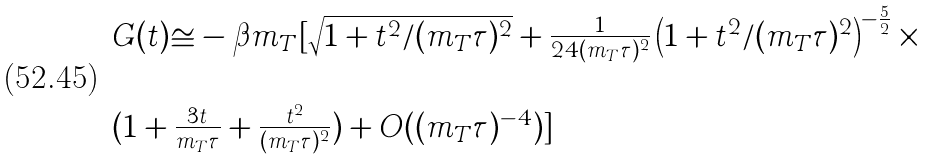Convert formula to latex. <formula><loc_0><loc_0><loc_500><loc_500>\begin{array} { l } G ( t ) \cong - \beta m _ { T } [ \sqrt { 1 + t ^ { 2 } / ( m _ { T } \tau ) ^ { 2 } } + \frac { 1 } { 2 4 ( m _ { T } \tau ) ^ { 2 } } \left ( 1 + t ^ { 2 } / ( m _ { T } \tau ) ^ { 2 } \right ) ^ { - \frac { 5 } { 2 } } \times \\ \\ ( 1 + \frac { 3 t } { m _ { T } \tau } + \frac { t ^ { 2 } } { ( m _ { T } \tau ) ^ { 2 } } ) + O ( ( m _ { T } \tau ) ^ { - 4 } ) ] \end{array}</formula> 